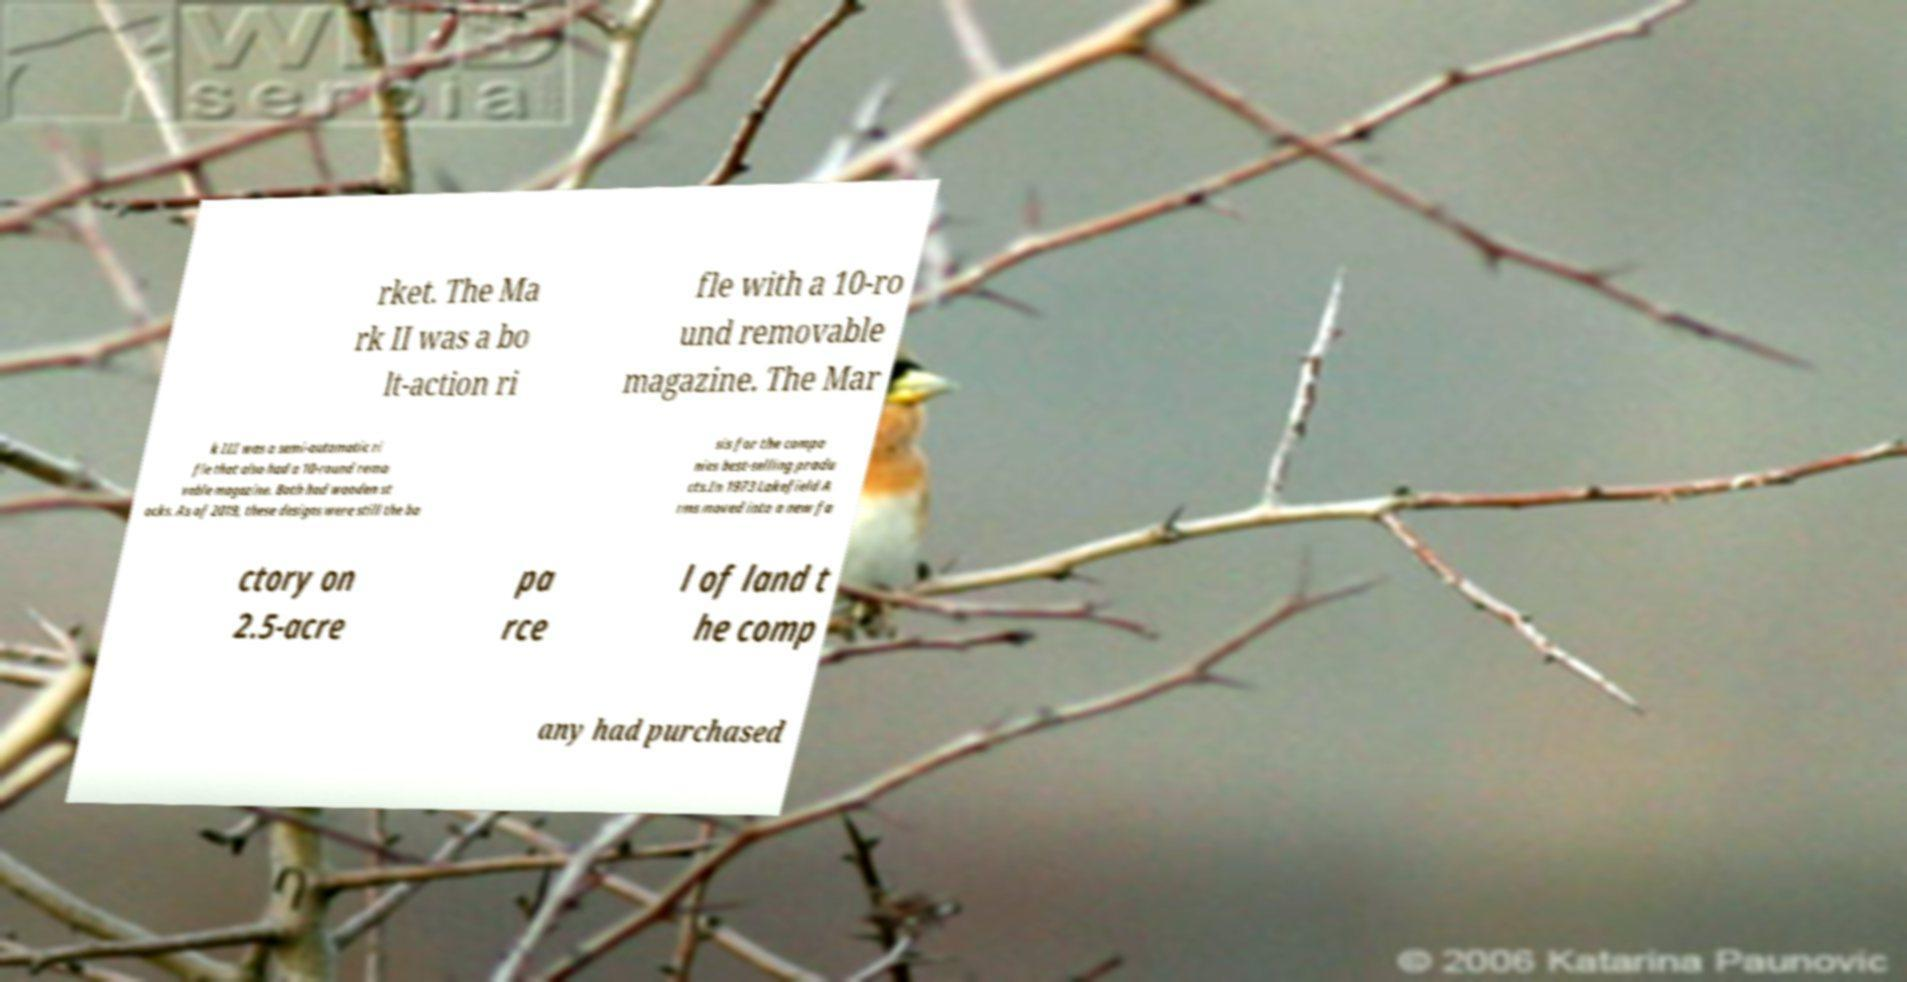Please read and relay the text visible in this image. What does it say? rket. The Ma rk II was a bo lt-action ri fle with a 10-ro und removable magazine. The Mar k III was a semi-automatic ri fle that also had a 10-round remo vable magazine. Both had wooden st ocks. As of 2019, these designs were still the ba sis for the compa nies best-selling produ cts.In 1973 Lakefield A rms moved into a new fa ctory on 2.5-acre pa rce l of land t he comp any had purchased 